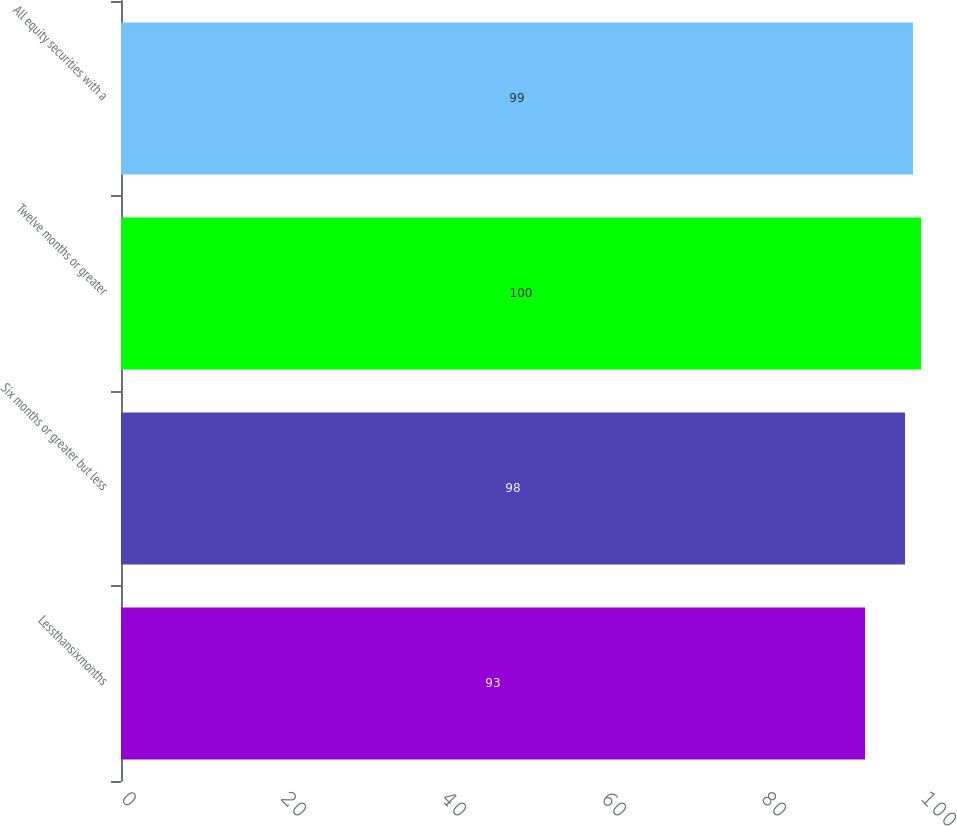Convert chart to OTSL. <chart><loc_0><loc_0><loc_500><loc_500><bar_chart><fcel>Lessthansixmonths<fcel>Six months or greater but less<fcel>Twelve months or greater<fcel>All equity securities with a<nl><fcel>93<fcel>98<fcel>100<fcel>99<nl></chart> 